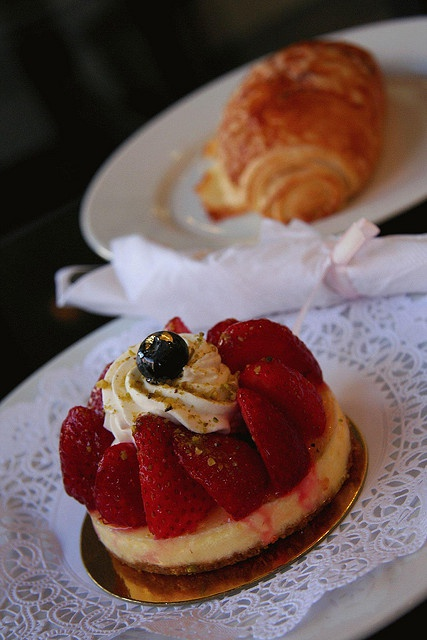Describe the objects in this image and their specific colors. I can see a cake in black, maroon, brown, and tan tones in this image. 